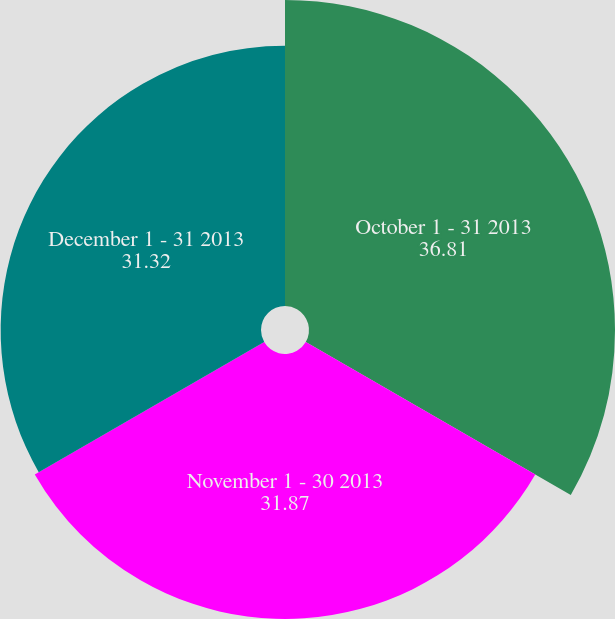<chart> <loc_0><loc_0><loc_500><loc_500><pie_chart><fcel>October 1 - 31 2013<fcel>November 1 - 30 2013<fcel>December 1 - 31 2013<nl><fcel>36.81%<fcel>31.87%<fcel>31.32%<nl></chart> 